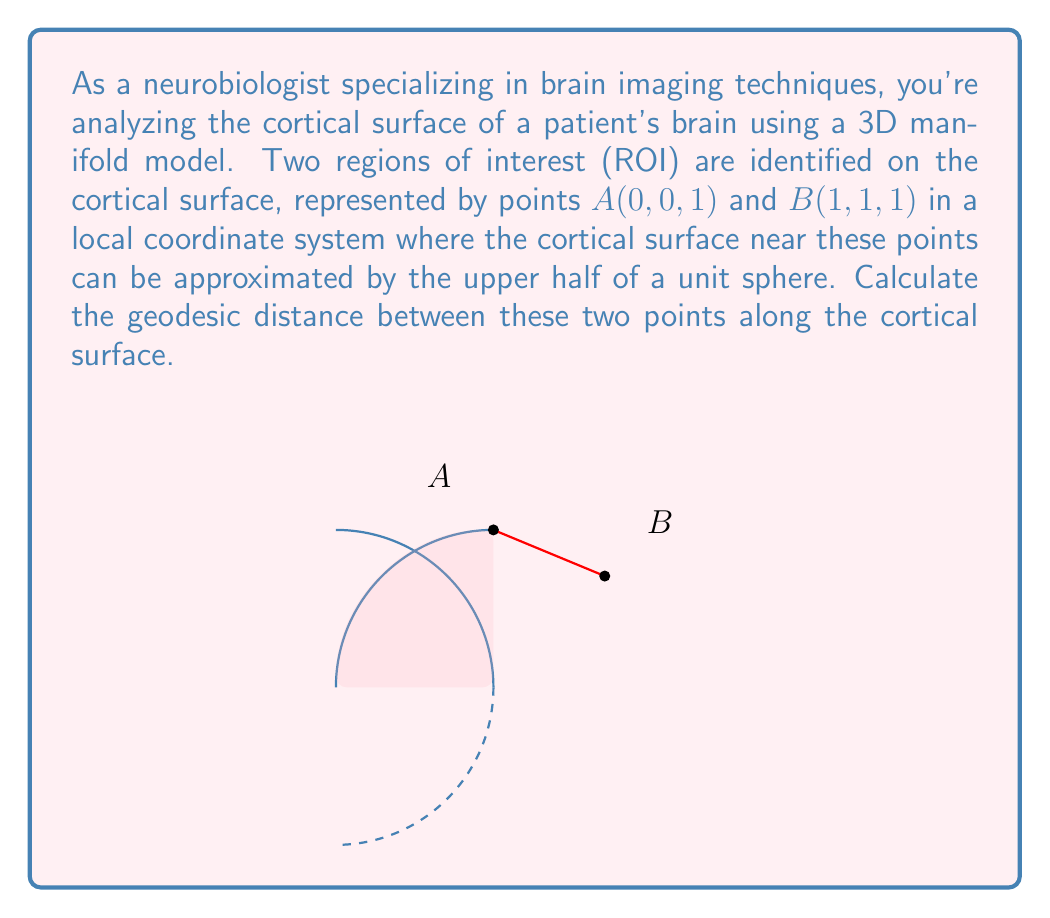What is the answer to this math problem? To solve this problem, we'll follow these steps:

1) First, we need to understand that the geodesic distance on a sphere is given by the great circle distance. The formula for this is:

   $$d = R \cdot \arccos(\sin\phi_1 \sin\phi_2 + \cos\phi_1 \cos\phi_2 \cos(\lambda_2 - \lambda_1))$$

   where $R$ is the radius of the sphere, $\phi$ is latitude, and $\lambda$ is longitude.

2) In our case, $R = 1$ (unit sphere). We need to convert our Cartesian coordinates to spherical coordinates.

3) For point A(0, 0, 1):
   $\phi_1 = 0$, $\lambda_1 = 0$ (this is the "North Pole" of our sphere)

4) For point B(1, 1, 1):
   We need to normalize this to be on the unit sphere:
   B'($\frac{1}{\sqrt{3}}$, $\frac{1}{\sqrt{3}}$, $\frac{1}{\sqrt{3}}$)
   
   Now we convert to spherical coordinates:
   $\phi_2 = \arccos(\frac{1}{\sqrt{3}}) = \arccos(\frac{\sqrt{3}}{3})$
   $\lambda_2 = \arctan(1) = \frac{\pi}{4}$

5) Plugging into our formula:

   $$d = \arccos(\sin(0) \sin(\arccos(\frac{\sqrt{3}}{3})) + \cos(0) \cos(\arccos(\frac{\sqrt{3}}{3})) \cos(\frac{\pi}{4} - 0))$$

6) Simplifying:
   $$d = \arccos(\frac{\sqrt{3}}{3} \cdot \frac{\sqrt{2}}{2})$$

7) This simplifies to:
   $$d = \arccos(\frac{\sqrt{6}}{6})$$

This is the geodesic distance in radians. If we wanted it in terms of arc length on the unit sphere, this would be our final answer.
Answer: $\arccos(\frac{\sqrt{6}}{6})$ radians 